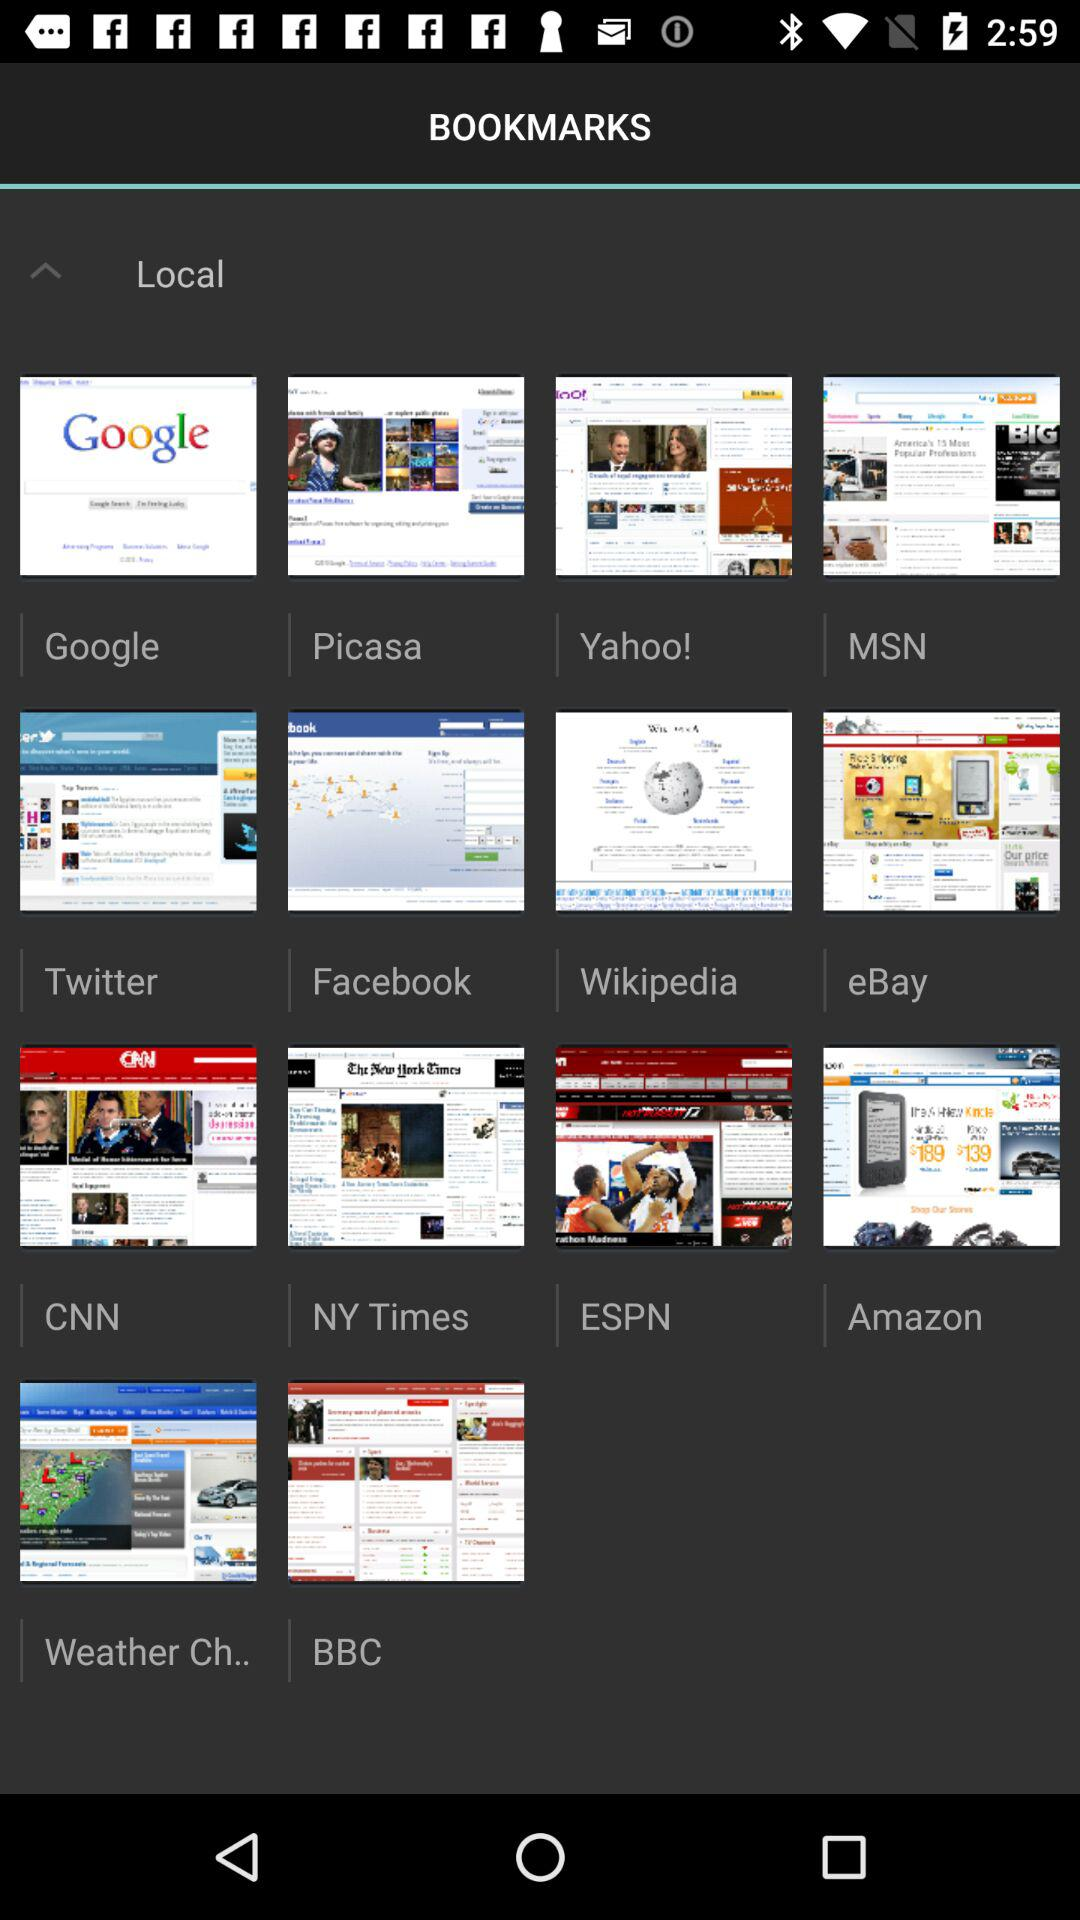What is the status of quick controls? The status of quick controls is off. 